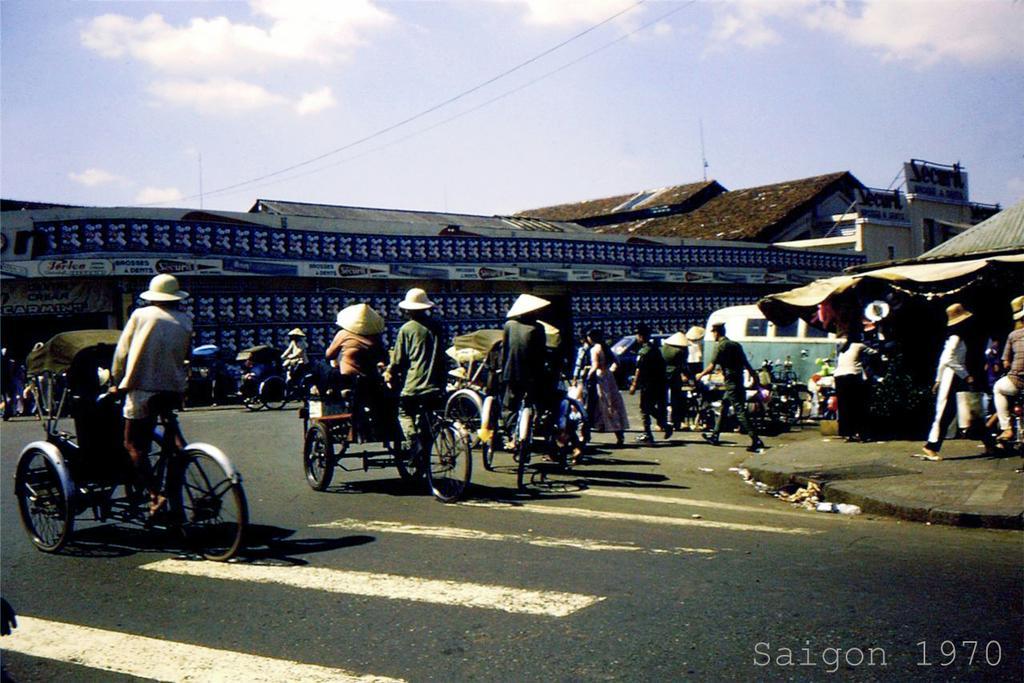Please provide a concise description of this image. In this image these people riding rickshaw on a road, in the background there house and the sky. 